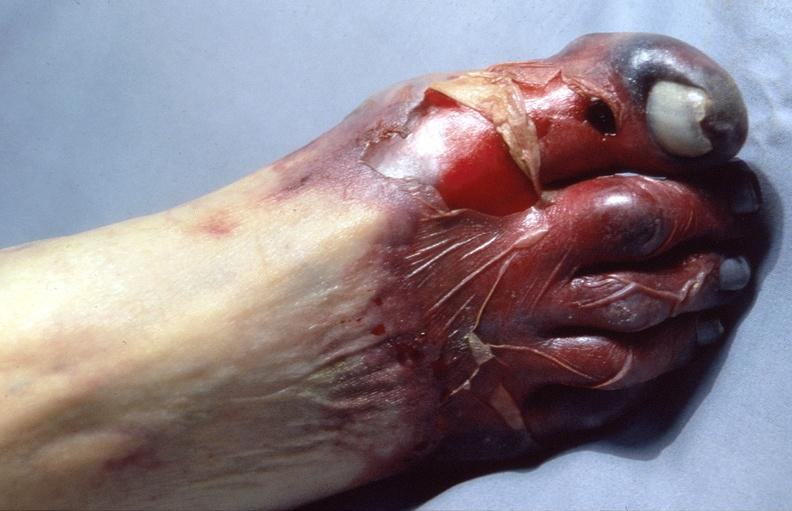why does this image show skin ulceration and necrosis, disseminated intravascular coagulation?
Answer the question using a single word or phrase. Due to acetaminophen toxicity 